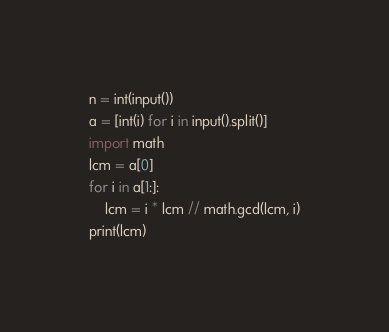<code> <loc_0><loc_0><loc_500><loc_500><_Python_>n = int(input())
a = [int(i) for i in input().split()]
import math
lcm = a[0]
for i in a[1:]:
    lcm = i * lcm // math.gcd(lcm, i)
print(lcm)
</code> 